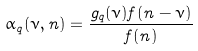Convert formula to latex. <formula><loc_0><loc_0><loc_500><loc_500>\alpha _ { q } ( \nu , n ) = \frac { g _ { q } ( \nu ) f ( n - \nu ) } { f ( n ) }</formula> 